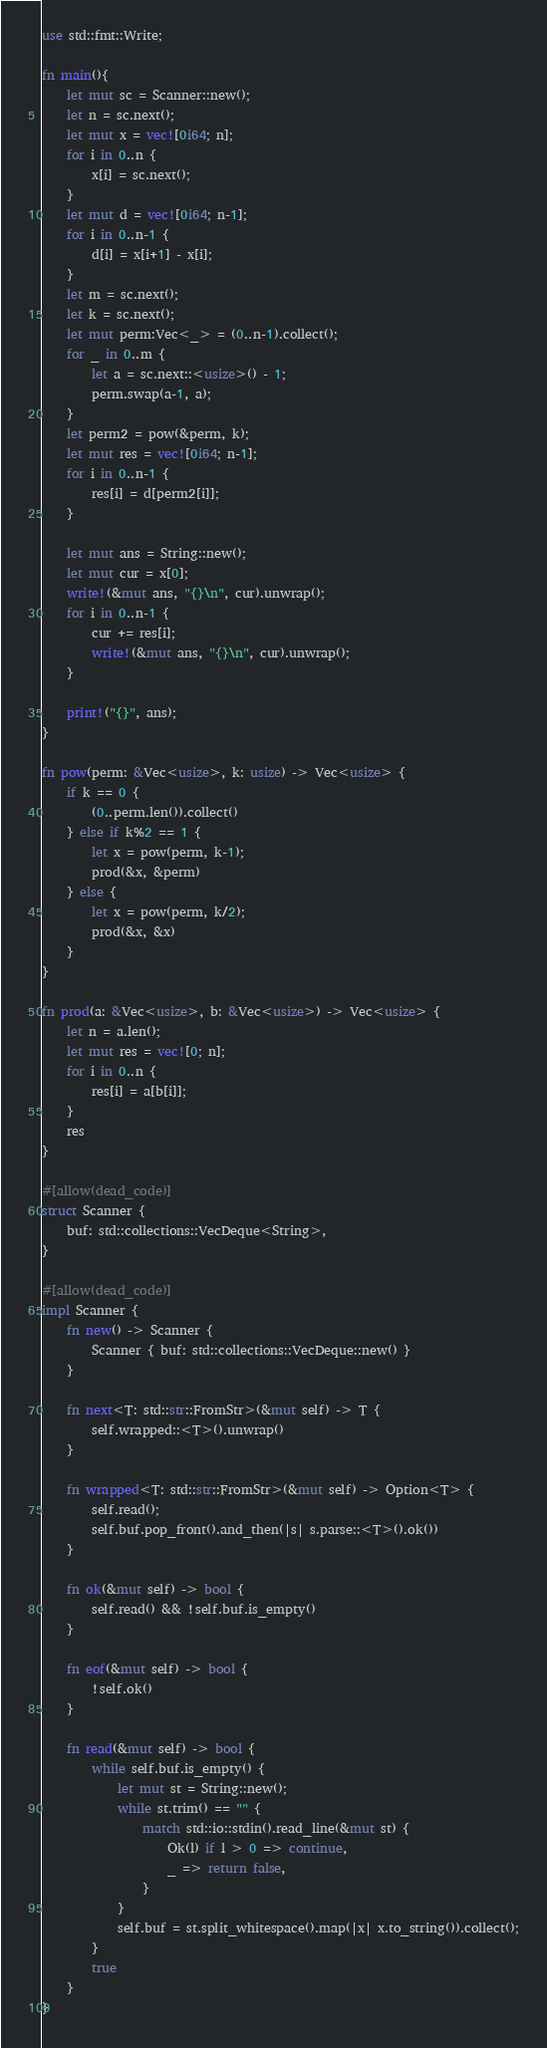Convert code to text. <code><loc_0><loc_0><loc_500><loc_500><_Rust_>use std::fmt::Write;

fn main(){
    let mut sc = Scanner::new();
    let n = sc.next();
    let mut x = vec![0i64; n];
    for i in 0..n {
        x[i] = sc.next();
    }
    let mut d = vec![0i64; n-1];
    for i in 0..n-1 {
        d[i] = x[i+1] - x[i];
    }
    let m = sc.next();
    let k = sc.next();
    let mut perm:Vec<_> = (0..n-1).collect();
    for _ in 0..m {
        let a = sc.next::<usize>() - 1;
        perm.swap(a-1, a);
    }
    let perm2 = pow(&perm, k);
    let mut res = vec![0i64; n-1];
    for i in 0..n-1 {
        res[i] = d[perm2[i]];
    }

    let mut ans = String::new();
    let mut cur = x[0];
    write!(&mut ans, "{}\n", cur).unwrap();
    for i in 0..n-1 {
        cur += res[i];
        write!(&mut ans, "{}\n", cur).unwrap();
    }

    print!("{}", ans);
}

fn pow(perm: &Vec<usize>, k: usize) -> Vec<usize> {
    if k == 0 {
        (0..perm.len()).collect()
    } else if k%2 == 1 {
        let x = pow(perm, k-1);
        prod(&x, &perm)
    } else {
        let x = pow(perm, k/2);
        prod(&x, &x)
    }
}

fn prod(a: &Vec<usize>, b: &Vec<usize>) -> Vec<usize> {
    let n = a.len();
    let mut res = vec![0; n];
    for i in 0..n {
        res[i] = a[b[i]];
    }
    res
}

#[allow(dead_code)]
struct Scanner {
    buf: std::collections::VecDeque<String>,
}

#[allow(dead_code)]
impl Scanner {
    fn new() -> Scanner {
        Scanner { buf: std::collections::VecDeque::new() }
    }

    fn next<T: std::str::FromStr>(&mut self) -> T {
        self.wrapped::<T>().unwrap()
    }

    fn wrapped<T: std::str::FromStr>(&mut self) -> Option<T> {
        self.read();
        self.buf.pop_front().and_then(|s| s.parse::<T>().ok())
    }

    fn ok(&mut self) -> bool {
        self.read() && !self.buf.is_empty()
    }

    fn eof(&mut self) -> bool {
        !self.ok()
    }

    fn read(&mut self) -> bool {
        while self.buf.is_empty() {
            let mut st = String::new();
            while st.trim() == "" {
                match std::io::stdin().read_line(&mut st) {
                    Ok(l) if l > 0 => continue,
                    _ => return false,
                }
            }
            self.buf = st.split_whitespace().map(|x| x.to_string()).collect();
        }
        true
    }
}
</code> 